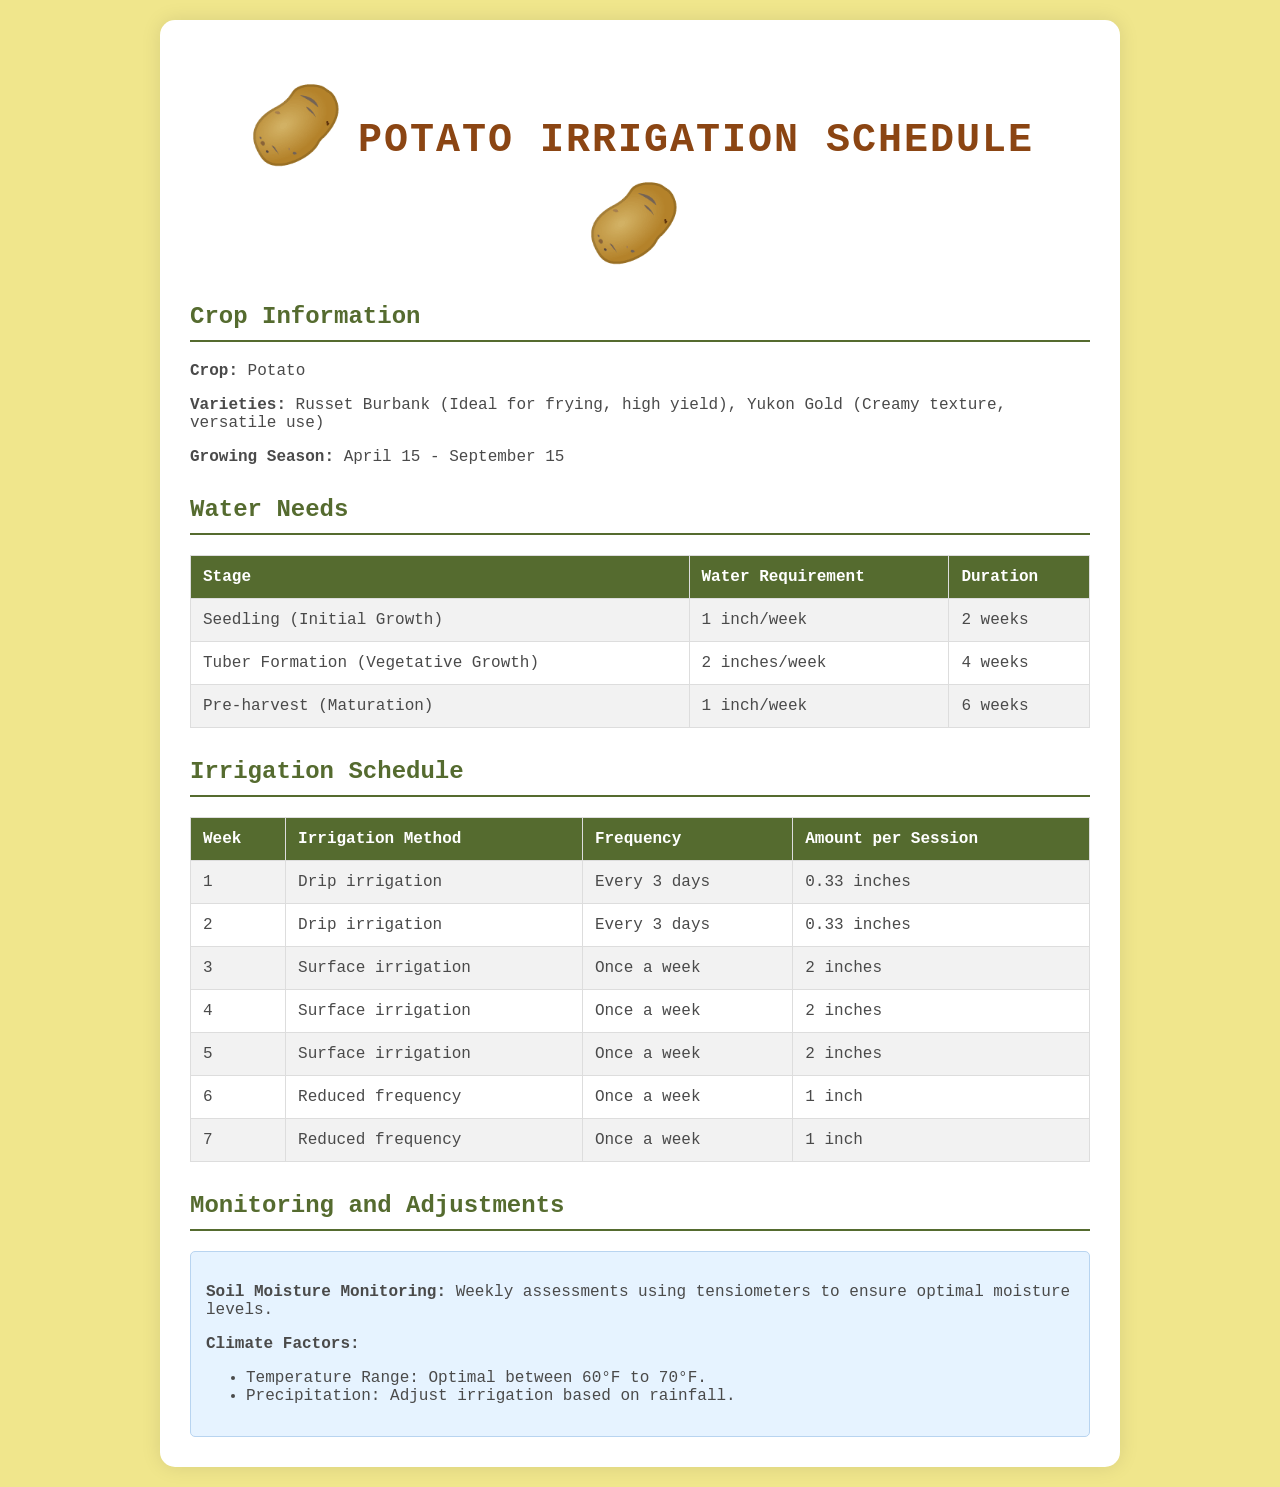What is the crop? The document states that the crop being discussed is potatoes.
Answer: Potato What are the two potato varieties? The document lists the two varieties as Russet Burbank and Yukon Gold.
Answer: Russet Burbank, Yukon Gold How many weeks is the seedling stage? The seedling stage lasts for 2 weeks, as indicated in the water needs section.
Answer: 2 weeks What irrigation method is used in week 3? The irrigation method specified for week 3 is surface irrigation.
Answer: Surface irrigation What is the water requirement during tuber formation? The document states that the water requirement during tuber formation is 2 inches per week.
Answer: 2 inches/week During which time frame does the growing season occur? The growing season is from April 15 to September 15, as mentioned in the crop information.
Answer: April 15 - September 15 What is the frequency of irrigation in week 6? Week 6 has a reduced frequency of irrigation specified as once a week.
Answer: Once a week What methodology is used for soil moisture monitoring? The document mentions using tensiometers for soil moisture monitoring weekly.
Answer: Tensiometers What is the optimal temperature range? The optimal temperature range for potato growth stated in the document is between 60°F to 70°F.
Answer: 60°F to 70°F 